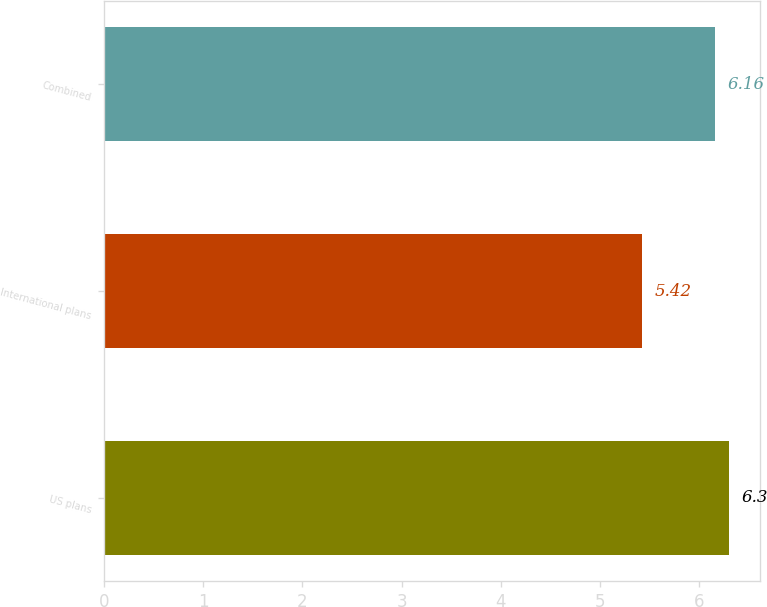<chart> <loc_0><loc_0><loc_500><loc_500><bar_chart><fcel>US plans<fcel>International plans<fcel>Combined<nl><fcel>6.3<fcel>5.42<fcel>6.16<nl></chart> 